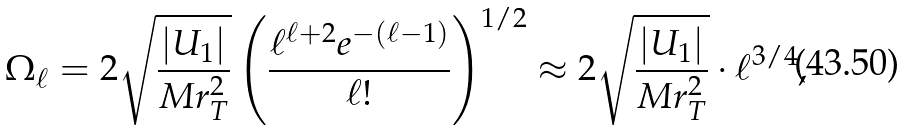<formula> <loc_0><loc_0><loc_500><loc_500>\Omega _ { \ell } = 2 \sqrt { \frac { | U _ { 1 } | } { M r _ { T } ^ { 2 } } } \left ( \frac { \ell ^ { \ell + 2 } e ^ { - ( \ell - 1 ) } } { \ell ! } \right ) ^ { 1 / 2 } \approx 2 \sqrt { \frac { | U _ { 1 } | } { M r _ { T } ^ { 2 } } } \cdot \ell ^ { 3 / 4 } ,</formula> 